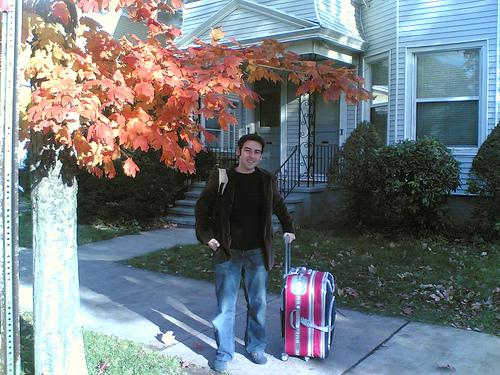Question: where was this picture taken?
Choices:
A. An amusement park.
B. At a fair.
C. At a water park.
D. A neighborhood.
Answer with the letter. Answer: D Question: what time of year is shown?
Choices:
A. The Winter.
B. The Fall.
C. The Spring.
D. The Autumn.
Answer with the letter. Answer: B Question: what color is the man's hair?
Choices:
A. Brown.
B. Blonde.
C. White.
D. Grey.
Answer with the letter. Answer: A 